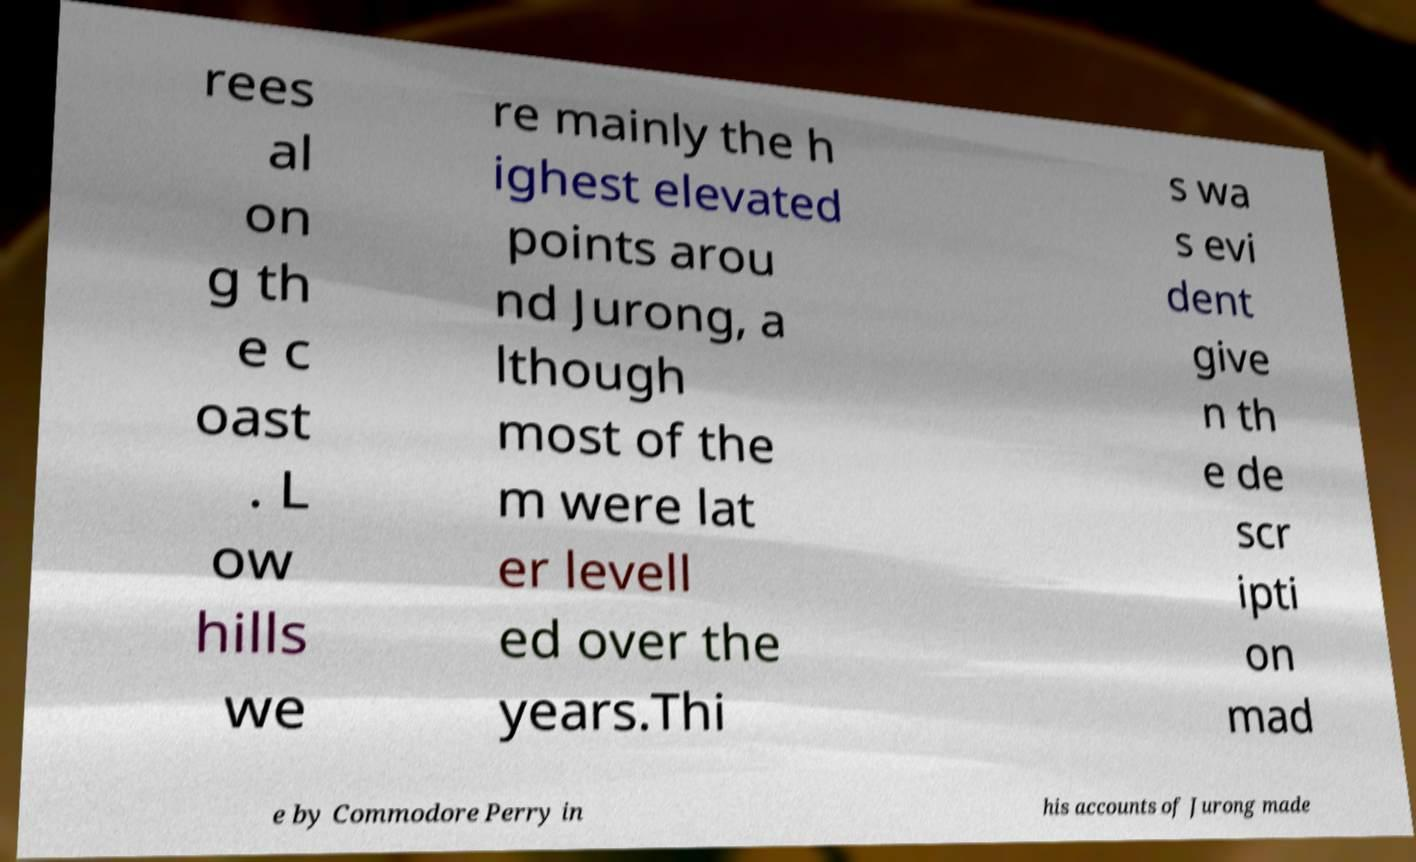Could you assist in decoding the text presented in this image and type it out clearly? rees al on g th e c oast . L ow hills we re mainly the h ighest elevated points arou nd Jurong, a lthough most of the m were lat er levell ed over the years.Thi s wa s evi dent give n th e de scr ipti on mad e by Commodore Perry in his accounts of Jurong made 